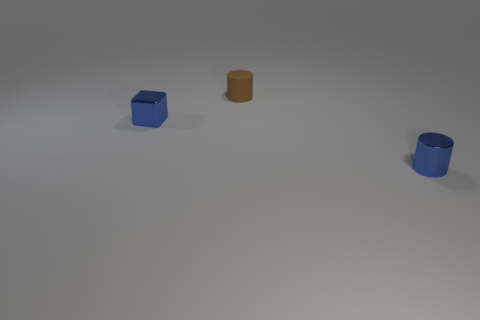How many things are either blue shiny objects or small blue things to the right of the small matte thing?
Provide a short and direct response. 2. What number of big cyan balls are there?
Your answer should be very brief. 0. Is there another shiny thing that has the same size as the brown thing?
Ensure brevity in your answer.  Yes. Are there fewer tiny blue cylinders in front of the blue metallic cylinder than cyan balls?
Provide a succinct answer. No. Do the brown rubber object and the block have the same size?
Give a very brief answer. Yes. The block that is made of the same material as the blue cylinder is what size?
Your answer should be compact. Small. How many metallic cylinders are the same color as the tiny cube?
Your answer should be compact. 1. Is the number of small blue things left of the brown rubber object less than the number of small cylinders right of the small cube?
Provide a succinct answer. Yes. There is a tiny thing left of the brown cylinder; is its shape the same as the matte object?
Give a very brief answer. No. Is there anything else that has the same material as the brown thing?
Your answer should be very brief. No. 